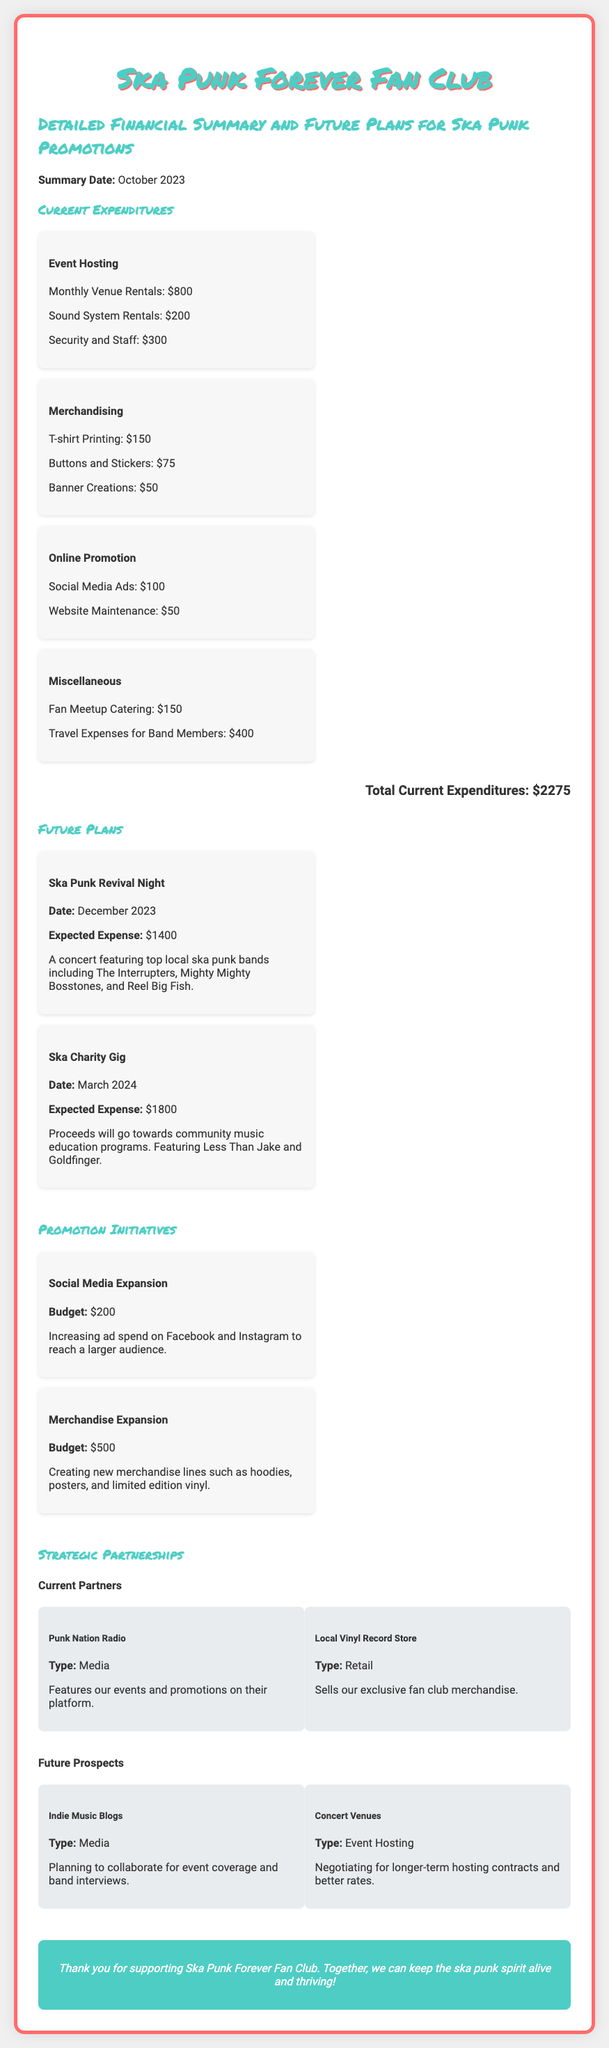what is the total current expenditures? The total current expenditures are calculated by summing up all listed expenses, which amounts to $800 + $200 + $300 + $150 + $75 + $50 + $100 + $50 + $150 + $400 = $2275.
Answer: $2275 what is the expected expense for the Ska Punk Revival Night? The expected expense for the Ska Punk Revival Night is detailed in the future plans section and is noted as $1400.
Answer: $1400 how many merchandise lines are planned for expansion? The document specifies the creation of new merchandise lines such as hoodies, posters, and limited edition vinyl, which indicates there are three types of merchandise lines planned.
Answer: three what type of event is planned for March 2024? The future plan for March 2024 describes a charity gig, which includes a concert featuring ska punk bands.
Answer: charity gig who are the current partners of the fan club? The document lists Punk Nation Radio and Local Vinyl Record Store as the current partners of the fan club.
Answer: Punk Nation Radio, Local Vinyl Record Store what is the budget for social media expansion? In the future plans section, the budget allocated for social media expansion is clearly stated as $200.
Answer: $200 how many bands are featured in the Ska Punk Revival Night? The document lists three bands that will be featured at the Ska Punk Revival Night: The Interrupters, Mighty Mighty Bosstones, and Reel Big Fish.
Answer: three what is the date for the Ska Charity Gig? The date for the Ska Charity Gig is given in the future plans section, which is March 2024.
Answer: March 2024 what is the type of the future prospect "Indie Music Blogs"? The document identifies "Indie Music Blogs" as a media type for future prospects regarding collaboration.
Answer: Media 